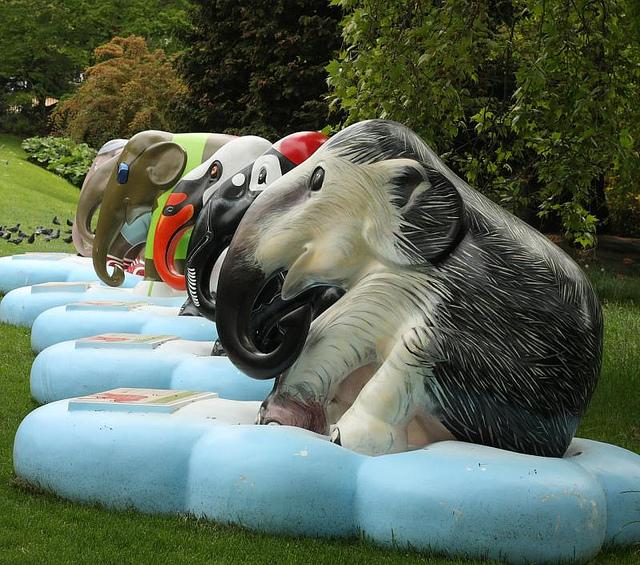How would these animals be described? Please explain your reasoning. human made. They have a shiny surface rather than the leathery skin that real animals have. 